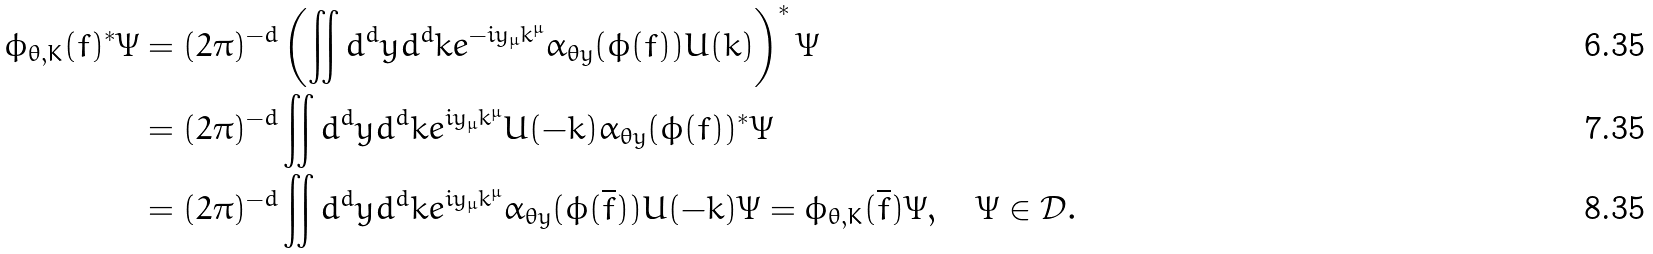Convert formula to latex. <formula><loc_0><loc_0><loc_500><loc_500>\phi _ { \theta , K } ( f ) ^ { * } \Psi & = ( 2 \pi ) ^ { - d } \left ( \iint d ^ { d } y d ^ { d } k e ^ { - i y _ { \mu } k ^ { \mu } } \alpha _ { \theta y } ( \phi ( f ) ) U ( k ) \right ) ^ { * } \Psi \\ & = ( 2 \pi ) ^ { - d } \iint d ^ { d } y d ^ { d } k e ^ { i y _ { \mu } k ^ { \mu } } U ( - k ) \alpha _ { \theta y } ( \phi ( f ) ) ^ { * } \Psi \\ & = ( 2 \pi ) ^ { - d } \iint d ^ { d } y d ^ { d } k e ^ { i y _ { \mu } k ^ { \mu } } \alpha _ { \theta y } ( \phi ( \overline { f } ) ) U ( - k ) \Psi = \phi _ { \theta , K } ( \overline { f } ) \Psi , \quad \Psi \in \mathcal { D } .</formula> 